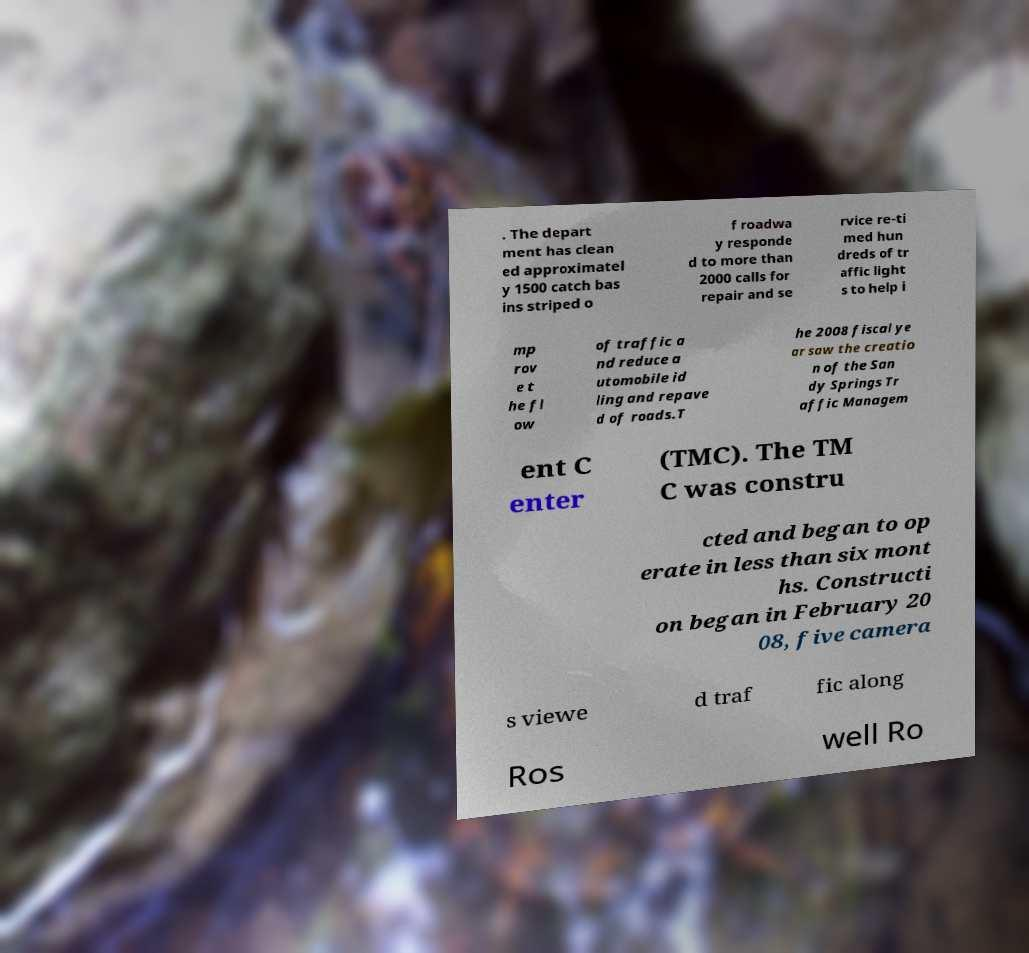Could you assist in decoding the text presented in this image and type it out clearly? . The depart ment has clean ed approximatel y 1500 catch bas ins striped o f roadwa y responde d to more than 2000 calls for repair and se rvice re-ti med hun dreds of tr affic light s to help i mp rov e t he fl ow of traffic a nd reduce a utomobile id ling and repave d of roads.T he 2008 fiscal ye ar saw the creatio n of the San dy Springs Tr affic Managem ent C enter (TMC). The TM C was constru cted and began to op erate in less than six mont hs. Constructi on began in February 20 08, five camera s viewe d traf fic along Ros well Ro 